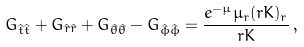<formula> <loc_0><loc_0><loc_500><loc_500>G _ { \hat { t } \hat { t } } + G _ { \hat { r } \hat { r } } + G _ { \hat { \theta } \hat { \theta } } - G _ { \hat { \phi } \hat { \phi } } = \frac { e ^ { - \mu } \mu _ { r } ( r K ) _ { r } } { r K } \, ,</formula> 